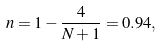Convert formula to latex. <formula><loc_0><loc_0><loc_500><loc_500>n = 1 - \frac { 4 } { N + 1 } = 0 . 9 4 ,</formula> 